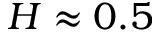<formula> <loc_0><loc_0><loc_500><loc_500>H \approx 0 . 5</formula> 